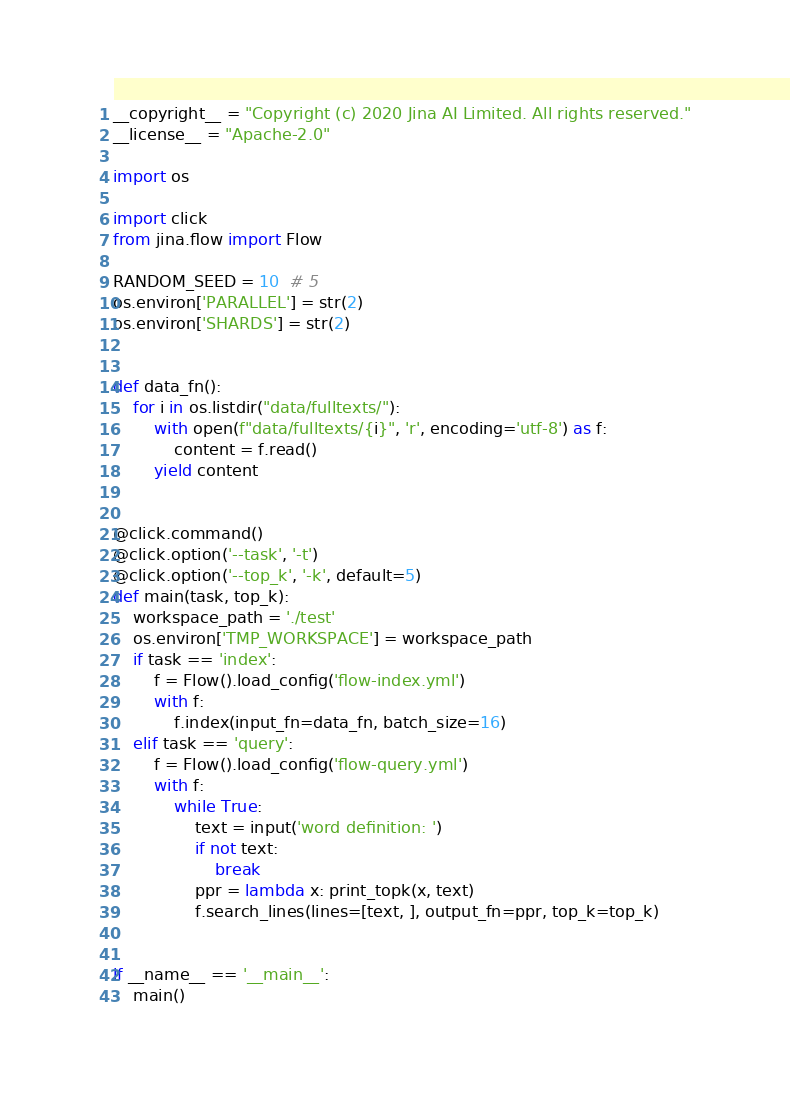<code> <loc_0><loc_0><loc_500><loc_500><_Python_>__copyright__ = "Copyright (c) 2020 Jina AI Limited. All rights reserved."
__license__ = "Apache-2.0"

import os

import click
from jina.flow import Flow

RANDOM_SEED = 10  # 5
os.environ['PARALLEL'] = str(2)
os.environ['SHARDS'] = str(2)


def data_fn():
    for i in os.listdir("data/fulltexts/"):
        with open(f"data/fulltexts/{i}", 'r', encoding='utf-8') as f:
            content = f.read()
        yield content


@click.command()
@click.option('--task', '-t')
@click.option('--top_k', '-k', default=5)
def main(task, top_k):
    workspace_path = './test'
    os.environ['TMP_WORKSPACE'] = workspace_path
    if task == 'index':
        f = Flow().load_config('flow-index.yml')
        with f:
            f.index(input_fn=data_fn, batch_size=16)
    elif task == 'query':
        f = Flow().load_config('flow-query.yml')
        with f:
            while True:
                text = input('word definition: ')
                if not text:
                    break
                ppr = lambda x: print_topk(x, text)
                f.search_lines(lines=[text, ], output_fn=ppr, top_k=top_k)


if __name__ == '__main__':
    main()
</code> 